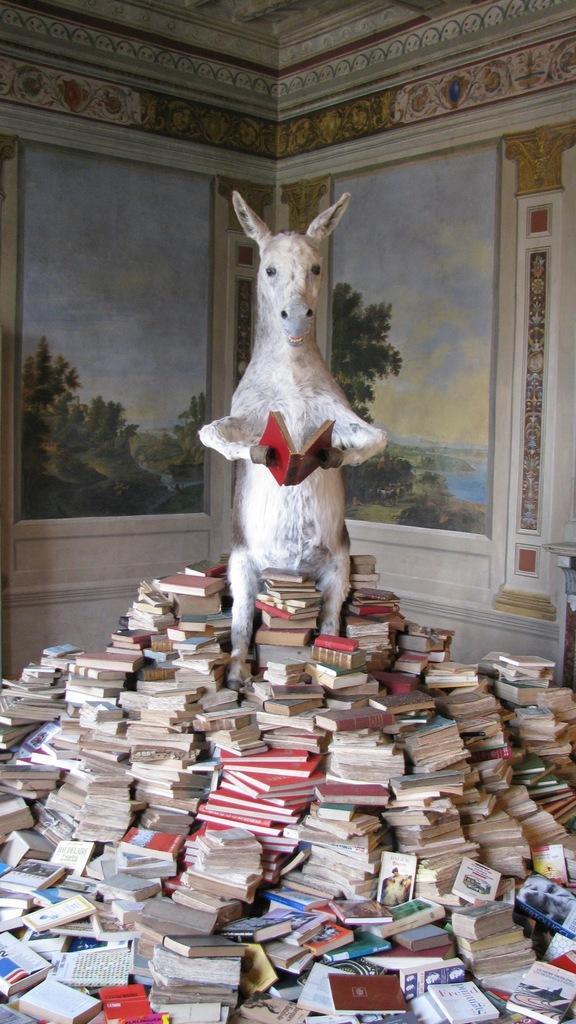Please provide a concise description of this image. In the background we can see the designed wall and painting on the wall. In this picture we can see the statue of an animal holding a book. Around the statue we can see the books. 